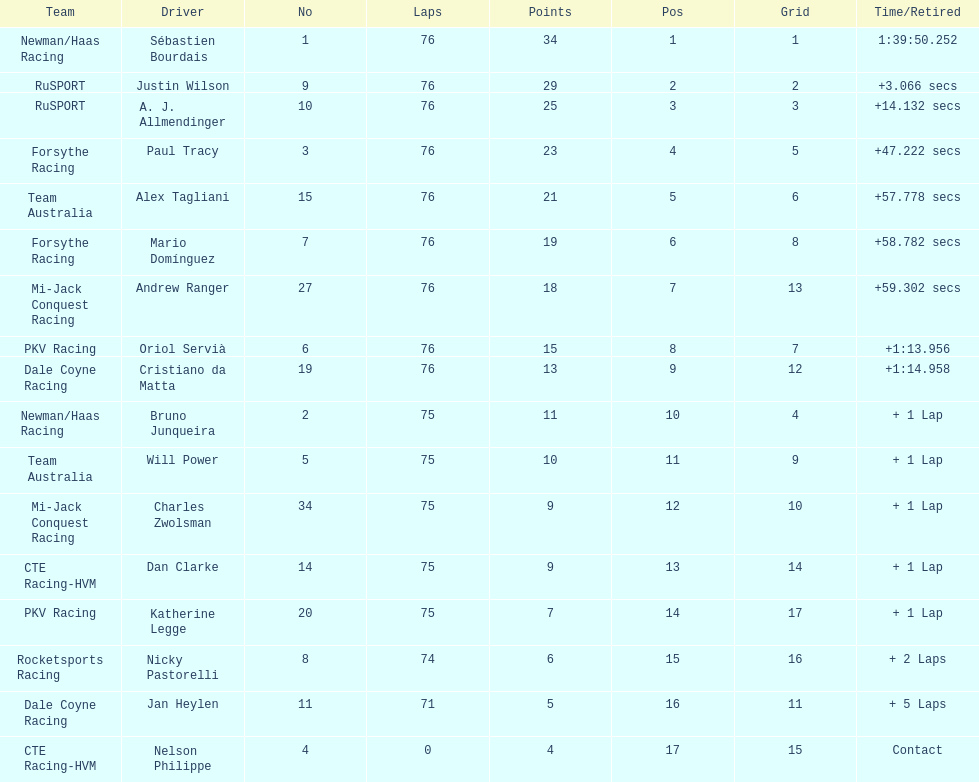How many positions are held by canada? 3. 